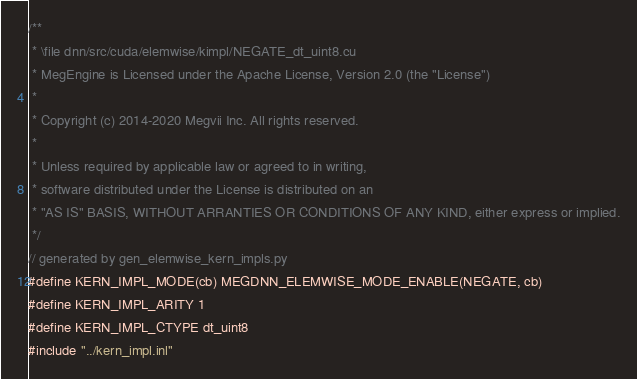Convert code to text. <code><loc_0><loc_0><loc_500><loc_500><_Cuda_>/**
 * \file dnn/src/cuda/elemwise/kimpl/NEGATE_dt_uint8.cu
 * MegEngine is Licensed under the Apache License, Version 2.0 (the "License")
 *
 * Copyright (c) 2014-2020 Megvii Inc. All rights reserved.
 *
 * Unless required by applicable law or agreed to in writing,
 * software distributed under the License is distributed on an
 * "AS IS" BASIS, WITHOUT ARRANTIES OR CONDITIONS OF ANY KIND, either express or implied.
 */
// generated by gen_elemwise_kern_impls.py
#define KERN_IMPL_MODE(cb) MEGDNN_ELEMWISE_MODE_ENABLE(NEGATE, cb)
#define KERN_IMPL_ARITY 1
#define KERN_IMPL_CTYPE dt_uint8
#include "../kern_impl.inl"
</code> 